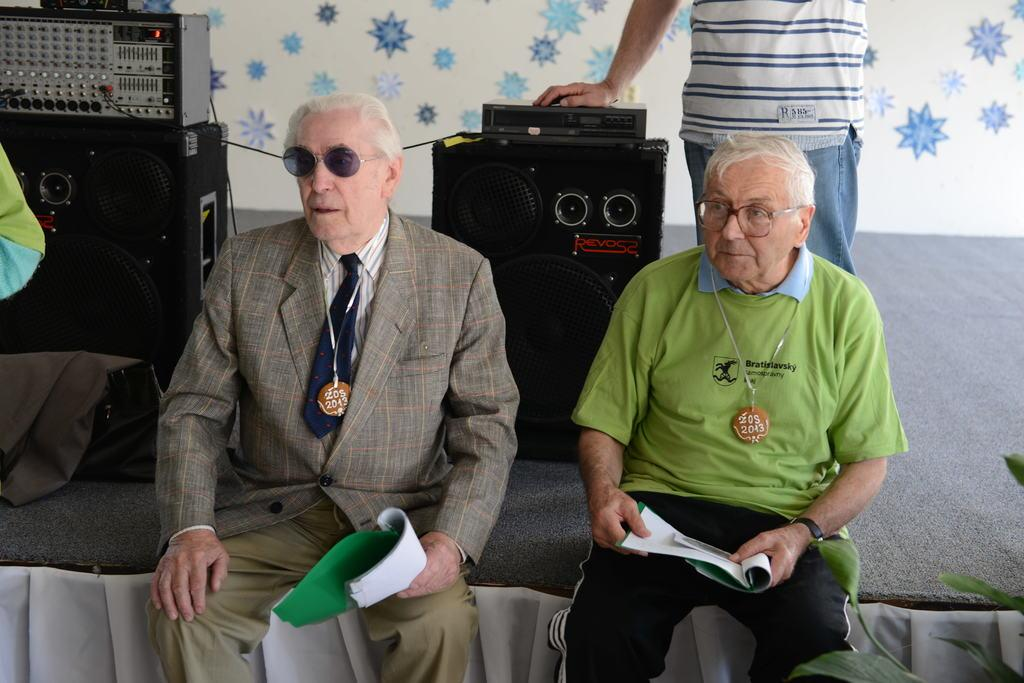How many old men are in the image? There are two old men in the image. Where are the old men sitting? The old men are sitting on a stage. What are the old men holding in the image? The old men are holding books. What can be seen near the old men on the stage? There are speakers visible in the image. Who else is on the stage with the old men? There is a man standing in the middle of the stage. What is behind the men and speakers on the stage? There is a wall behind the men and speakers. What type of basin is visible on the stage in the image? There is no basin present on the stage in the image. How many cars are parked behind the wall in the image? There is no information about cars or parking in the image; it only shows the stage with the old men, speakers, and a wall. 